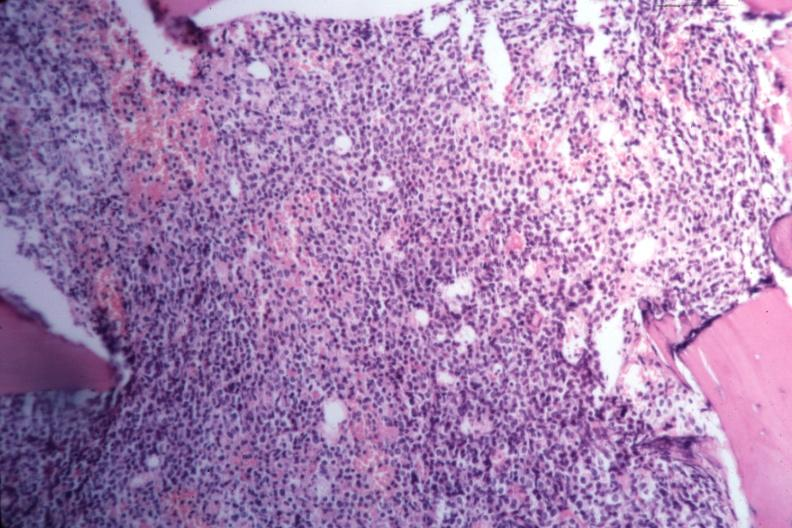s supernumerary digit present?
Answer the question using a single word or phrase. No 